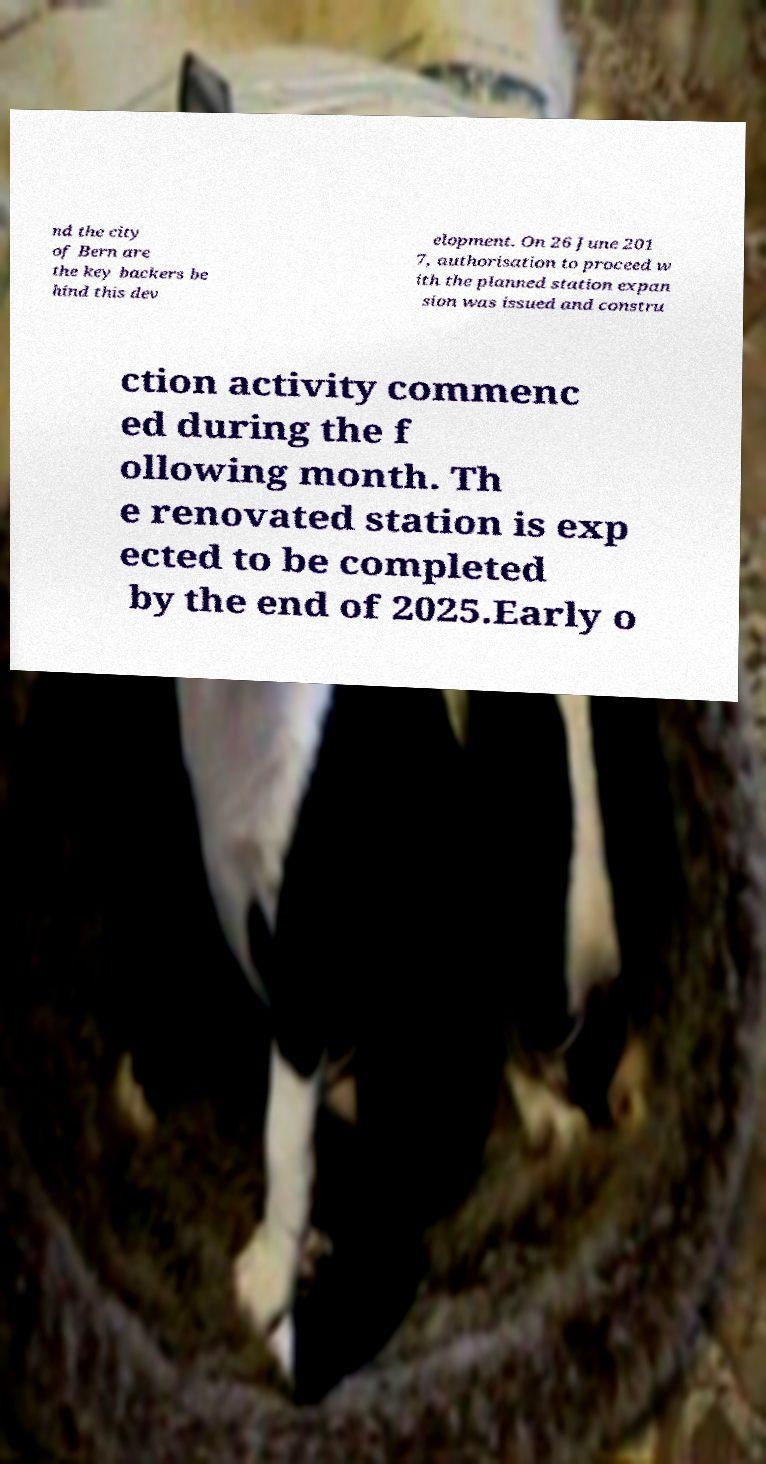Please read and relay the text visible in this image. What does it say? nd the city of Bern are the key backers be hind this dev elopment. On 26 June 201 7, authorisation to proceed w ith the planned station expan sion was issued and constru ction activity commenc ed during the f ollowing month. Th e renovated station is exp ected to be completed by the end of 2025.Early o 